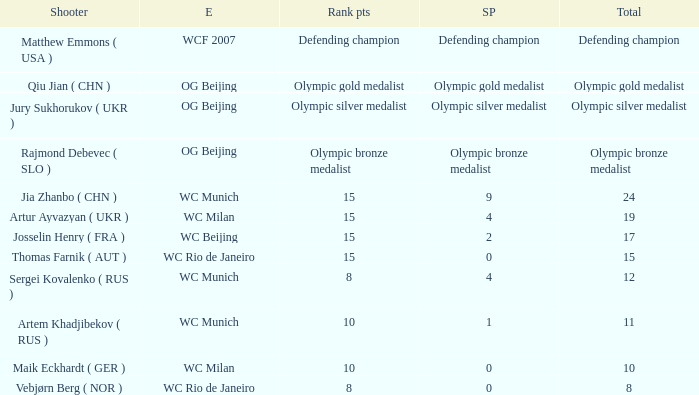Who is the shooter with 15 rank points, and 0 score points? Thomas Farnik ( AUT ). 